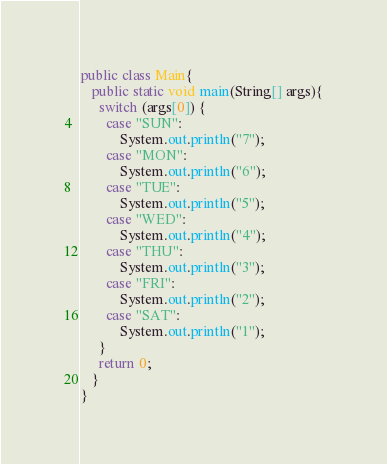<code> <loc_0><loc_0><loc_500><loc_500><_Java_>public class Main{
   public static void main(String[] args){
     switch (args[0]) {
       case "SUN":
           System.out.println("7");
       case "MON":
           System.out.println("6");
       case "TUE":
           System.out.println("5");
       case "WED":
           System.out.println("4");
       case "THU":
           System.out.println("3");
       case "FRI":
           System.out.println("2");
       case "SAT":
           System.out.println("1");
     }
     return 0;
   }
}</code> 